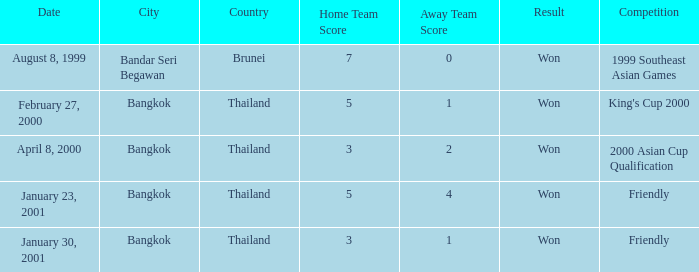What was the result of the 2000 king's cup? 5–1. 